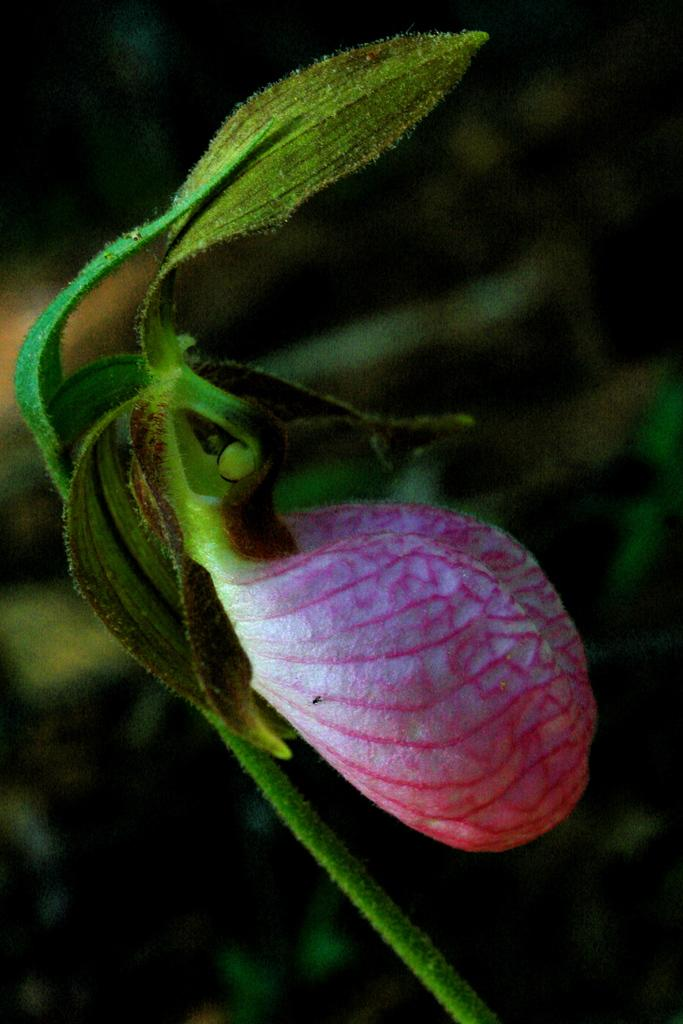What type of plant is visible in the image? There is a plant with a flower in the image. Can you describe the background of the image? The background of the image is blurred. What type of parenting advice can be seen in the image? There is no parenting advice present in the image; it features a plant with a flower and a blurred background. 